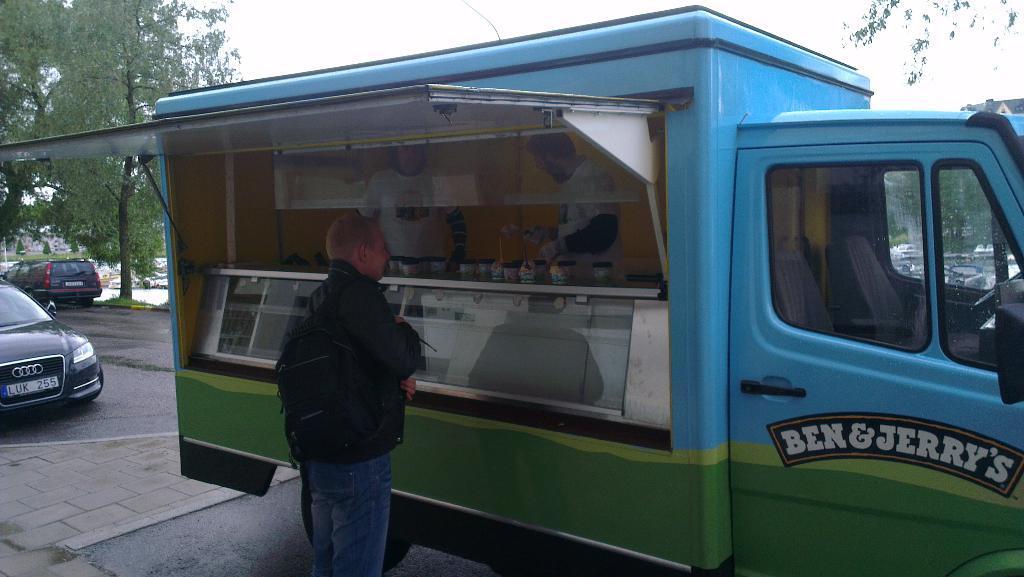How would you summarize this image in a sentence or two? This image is taken outdoors. At the top of the image there is the sky. At the bottom of the image there is a road. On the left side of the image there is a tree and two cars are parked on the road. In the background many cars are parked on the ground. In the middle of the image a truck is parked on the road and there is a text on the truck. There is a stall in the truck and two men are standing in the truck. A man is standing on the road. 